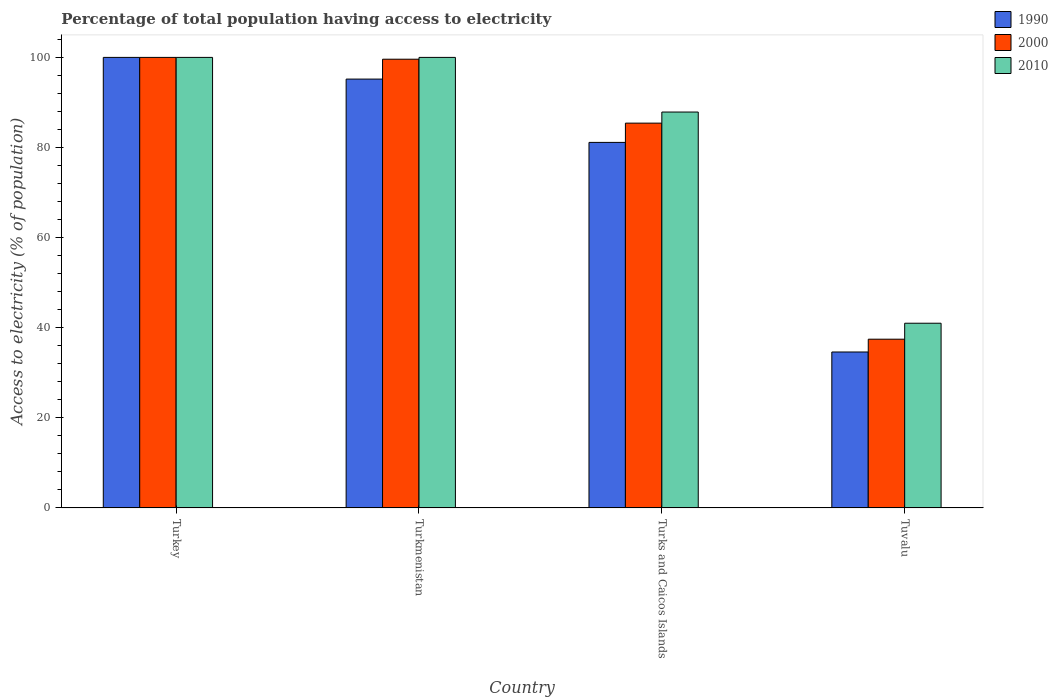Are the number of bars on each tick of the X-axis equal?
Provide a succinct answer. Yes. How many bars are there on the 3rd tick from the right?
Your answer should be compact. 3. What is the label of the 3rd group of bars from the left?
Provide a short and direct response. Turks and Caicos Islands. Across all countries, what is the minimum percentage of population that have access to electricity in 2010?
Provide a succinct answer. 41. In which country was the percentage of population that have access to electricity in 2010 maximum?
Give a very brief answer. Turkey. In which country was the percentage of population that have access to electricity in 2000 minimum?
Keep it short and to the point. Tuvalu. What is the total percentage of population that have access to electricity in 2000 in the graph?
Provide a short and direct response. 322.47. What is the difference between the percentage of population that have access to electricity in 2000 in Turkmenistan and that in Tuvalu?
Give a very brief answer. 62.14. What is the difference between the percentage of population that have access to electricity in 2010 in Tuvalu and the percentage of population that have access to electricity in 2000 in Turks and Caicos Islands?
Your answer should be compact. -44.41. What is the average percentage of population that have access to electricity in 2000 per country?
Offer a terse response. 80.62. What is the difference between the percentage of population that have access to electricity of/in 2000 and percentage of population that have access to electricity of/in 2010 in Turkmenistan?
Offer a terse response. -0.4. What is the ratio of the percentage of population that have access to electricity in 2000 in Turkey to that in Turks and Caicos Islands?
Offer a terse response. 1.17. Is the difference between the percentage of population that have access to electricity in 2000 in Turkmenistan and Turks and Caicos Islands greater than the difference between the percentage of population that have access to electricity in 2010 in Turkmenistan and Turks and Caicos Islands?
Your answer should be compact. Yes. What is the difference between the highest and the second highest percentage of population that have access to electricity in 1990?
Your answer should be compact. -18.86. What is the difference between the highest and the lowest percentage of population that have access to electricity in 2000?
Offer a very short reply. 62.54. In how many countries, is the percentage of population that have access to electricity in 1990 greater than the average percentage of population that have access to electricity in 1990 taken over all countries?
Your response must be concise. 3. Is the sum of the percentage of population that have access to electricity in 2010 in Turkey and Turkmenistan greater than the maximum percentage of population that have access to electricity in 1990 across all countries?
Make the answer very short. Yes. What does the 3rd bar from the left in Turkey represents?
Your answer should be compact. 2010. What does the 1st bar from the right in Tuvalu represents?
Your response must be concise. 2010. Is it the case that in every country, the sum of the percentage of population that have access to electricity in 1990 and percentage of population that have access to electricity in 2010 is greater than the percentage of population that have access to electricity in 2000?
Your response must be concise. Yes. How many bars are there?
Ensure brevity in your answer.  12. Are all the bars in the graph horizontal?
Your answer should be very brief. No. Are the values on the major ticks of Y-axis written in scientific E-notation?
Offer a terse response. No. Does the graph contain any zero values?
Offer a very short reply. No. Does the graph contain grids?
Make the answer very short. No. Where does the legend appear in the graph?
Provide a succinct answer. Top right. How many legend labels are there?
Offer a terse response. 3. What is the title of the graph?
Your answer should be compact. Percentage of total population having access to electricity. Does "2007" appear as one of the legend labels in the graph?
Ensure brevity in your answer.  No. What is the label or title of the Y-axis?
Provide a succinct answer. Access to electricity (% of population). What is the Access to electricity (% of population) in 2000 in Turkey?
Provide a succinct answer. 100. What is the Access to electricity (% of population) in 1990 in Turkmenistan?
Your response must be concise. 95.19. What is the Access to electricity (% of population) in 2000 in Turkmenistan?
Make the answer very short. 99.6. What is the Access to electricity (% of population) in 1990 in Turks and Caicos Islands?
Your answer should be compact. 81.14. What is the Access to electricity (% of population) of 2000 in Turks and Caicos Islands?
Your response must be concise. 85.41. What is the Access to electricity (% of population) in 2010 in Turks and Caicos Islands?
Ensure brevity in your answer.  87.87. What is the Access to electricity (% of population) in 1990 in Tuvalu?
Give a very brief answer. 34.62. What is the Access to electricity (% of population) in 2000 in Tuvalu?
Your answer should be compact. 37.46. What is the Access to electricity (% of population) of 2010 in Tuvalu?
Provide a succinct answer. 41. Across all countries, what is the maximum Access to electricity (% of population) of 1990?
Offer a terse response. 100. Across all countries, what is the maximum Access to electricity (% of population) of 2010?
Ensure brevity in your answer.  100. Across all countries, what is the minimum Access to electricity (% of population) in 1990?
Make the answer very short. 34.62. Across all countries, what is the minimum Access to electricity (% of population) of 2000?
Provide a short and direct response. 37.46. Across all countries, what is the minimum Access to electricity (% of population) in 2010?
Ensure brevity in your answer.  41. What is the total Access to electricity (% of population) in 1990 in the graph?
Your answer should be compact. 310.94. What is the total Access to electricity (% of population) in 2000 in the graph?
Your answer should be compact. 322.47. What is the total Access to electricity (% of population) of 2010 in the graph?
Your answer should be compact. 328.87. What is the difference between the Access to electricity (% of population) in 1990 in Turkey and that in Turkmenistan?
Provide a short and direct response. 4.81. What is the difference between the Access to electricity (% of population) in 2000 in Turkey and that in Turkmenistan?
Your response must be concise. 0.4. What is the difference between the Access to electricity (% of population) in 2010 in Turkey and that in Turkmenistan?
Offer a very short reply. 0. What is the difference between the Access to electricity (% of population) in 1990 in Turkey and that in Turks and Caicos Islands?
Ensure brevity in your answer.  18.86. What is the difference between the Access to electricity (% of population) in 2000 in Turkey and that in Turks and Caicos Islands?
Give a very brief answer. 14.59. What is the difference between the Access to electricity (% of population) of 2010 in Turkey and that in Turks and Caicos Islands?
Give a very brief answer. 12.13. What is the difference between the Access to electricity (% of population) of 1990 in Turkey and that in Tuvalu?
Provide a short and direct response. 65.38. What is the difference between the Access to electricity (% of population) of 2000 in Turkey and that in Tuvalu?
Offer a terse response. 62.54. What is the difference between the Access to electricity (% of population) in 2010 in Turkey and that in Tuvalu?
Your answer should be very brief. 59. What is the difference between the Access to electricity (% of population) of 1990 in Turkmenistan and that in Turks and Caicos Islands?
Ensure brevity in your answer.  14.05. What is the difference between the Access to electricity (% of population) of 2000 in Turkmenistan and that in Turks and Caicos Islands?
Offer a terse response. 14.19. What is the difference between the Access to electricity (% of population) of 2010 in Turkmenistan and that in Turks and Caicos Islands?
Offer a very short reply. 12.13. What is the difference between the Access to electricity (% of population) in 1990 in Turkmenistan and that in Tuvalu?
Ensure brevity in your answer.  60.57. What is the difference between the Access to electricity (% of population) of 2000 in Turkmenistan and that in Tuvalu?
Offer a terse response. 62.14. What is the difference between the Access to electricity (% of population) in 2010 in Turkmenistan and that in Tuvalu?
Provide a short and direct response. 59. What is the difference between the Access to electricity (% of population) of 1990 in Turks and Caicos Islands and that in Tuvalu?
Offer a very short reply. 46.52. What is the difference between the Access to electricity (% of population) of 2000 in Turks and Caicos Islands and that in Tuvalu?
Provide a short and direct response. 47.96. What is the difference between the Access to electricity (% of population) in 2010 in Turks and Caicos Islands and that in Tuvalu?
Provide a short and direct response. 46.87. What is the difference between the Access to electricity (% of population) of 1990 in Turkey and the Access to electricity (% of population) of 2000 in Turkmenistan?
Offer a terse response. 0.4. What is the difference between the Access to electricity (% of population) in 2000 in Turkey and the Access to electricity (% of population) in 2010 in Turkmenistan?
Offer a very short reply. 0. What is the difference between the Access to electricity (% of population) in 1990 in Turkey and the Access to electricity (% of population) in 2000 in Turks and Caicos Islands?
Give a very brief answer. 14.59. What is the difference between the Access to electricity (% of population) of 1990 in Turkey and the Access to electricity (% of population) of 2010 in Turks and Caicos Islands?
Your answer should be compact. 12.13. What is the difference between the Access to electricity (% of population) of 2000 in Turkey and the Access to electricity (% of population) of 2010 in Turks and Caicos Islands?
Your answer should be very brief. 12.13. What is the difference between the Access to electricity (% of population) of 1990 in Turkey and the Access to electricity (% of population) of 2000 in Tuvalu?
Your response must be concise. 62.54. What is the difference between the Access to electricity (% of population) of 1990 in Turkey and the Access to electricity (% of population) of 2010 in Tuvalu?
Your answer should be very brief. 59. What is the difference between the Access to electricity (% of population) of 1990 in Turkmenistan and the Access to electricity (% of population) of 2000 in Turks and Caicos Islands?
Your answer should be very brief. 9.78. What is the difference between the Access to electricity (% of population) of 1990 in Turkmenistan and the Access to electricity (% of population) of 2010 in Turks and Caicos Islands?
Your answer should be very brief. 7.31. What is the difference between the Access to electricity (% of population) of 2000 in Turkmenistan and the Access to electricity (% of population) of 2010 in Turks and Caicos Islands?
Your answer should be very brief. 11.73. What is the difference between the Access to electricity (% of population) of 1990 in Turkmenistan and the Access to electricity (% of population) of 2000 in Tuvalu?
Keep it short and to the point. 57.73. What is the difference between the Access to electricity (% of population) of 1990 in Turkmenistan and the Access to electricity (% of population) of 2010 in Tuvalu?
Give a very brief answer. 54.19. What is the difference between the Access to electricity (% of population) of 2000 in Turkmenistan and the Access to electricity (% of population) of 2010 in Tuvalu?
Give a very brief answer. 58.6. What is the difference between the Access to electricity (% of population) of 1990 in Turks and Caicos Islands and the Access to electricity (% of population) of 2000 in Tuvalu?
Make the answer very short. 43.68. What is the difference between the Access to electricity (% of population) of 1990 in Turks and Caicos Islands and the Access to electricity (% of population) of 2010 in Tuvalu?
Make the answer very short. 40.14. What is the difference between the Access to electricity (% of population) in 2000 in Turks and Caicos Islands and the Access to electricity (% of population) in 2010 in Tuvalu?
Offer a very short reply. 44.41. What is the average Access to electricity (% of population) in 1990 per country?
Offer a terse response. 77.73. What is the average Access to electricity (% of population) in 2000 per country?
Your answer should be compact. 80.62. What is the average Access to electricity (% of population) in 2010 per country?
Your answer should be very brief. 82.22. What is the difference between the Access to electricity (% of population) of 1990 and Access to electricity (% of population) of 2010 in Turkey?
Ensure brevity in your answer.  0. What is the difference between the Access to electricity (% of population) of 1990 and Access to electricity (% of population) of 2000 in Turkmenistan?
Provide a succinct answer. -4.41. What is the difference between the Access to electricity (% of population) of 1990 and Access to electricity (% of population) of 2010 in Turkmenistan?
Give a very brief answer. -4.81. What is the difference between the Access to electricity (% of population) of 2000 and Access to electricity (% of population) of 2010 in Turkmenistan?
Your response must be concise. -0.4. What is the difference between the Access to electricity (% of population) in 1990 and Access to electricity (% of population) in 2000 in Turks and Caicos Islands?
Offer a terse response. -4.28. What is the difference between the Access to electricity (% of population) of 1990 and Access to electricity (% of population) of 2010 in Turks and Caicos Islands?
Your answer should be compact. -6.74. What is the difference between the Access to electricity (% of population) of 2000 and Access to electricity (% of population) of 2010 in Turks and Caicos Islands?
Your response must be concise. -2.46. What is the difference between the Access to electricity (% of population) in 1990 and Access to electricity (% of population) in 2000 in Tuvalu?
Provide a short and direct response. -2.84. What is the difference between the Access to electricity (% of population) of 1990 and Access to electricity (% of population) of 2010 in Tuvalu?
Your answer should be compact. -6.38. What is the difference between the Access to electricity (% of population) of 2000 and Access to electricity (% of population) of 2010 in Tuvalu?
Keep it short and to the point. -3.54. What is the ratio of the Access to electricity (% of population) in 1990 in Turkey to that in Turkmenistan?
Ensure brevity in your answer.  1.05. What is the ratio of the Access to electricity (% of population) of 1990 in Turkey to that in Turks and Caicos Islands?
Make the answer very short. 1.23. What is the ratio of the Access to electricity (% of population) in 2000 in Turkey to that in Turks and Caicos Islands?
Provide a succinct answer. 1.17. What is the ratio of the Access to electricity (% of population) in 2010 in Turkey to that in Turks and Caicos Islands?
Your response must be concise. 1.14. What is the ratio of the Access to electricity (% of population) in 1990 in Turkey to that in Tuvalu?
Your response must be concise. 2.89. What is the ratio of the Access to electricity (% of population) in 2000 in Turkey to that in Tuvalu?
Provide a succinct answer. 2.67. What is the ratio of the Access to electricity (% of population) in 2010 in Turkey to that in Tuvalu?
Ensure brevity in your answer.  2.44. What is the ratio of the Access to electricity (% of population) of 1990 in Turkmenistan to that in Turks and Caicos Islands?
Make the answer very short. 1.17. What is the ratio of the Access to electricity (% of population) in 2000 in Turkmenistan to that in Turks and Caicos Islands?
Give a very brief answer. 1.17. What is the ratio of the Access to electricity (% of population) in 2010 in Turkmenistan to that in Turks and Caicos Islands?
Your response must be concise. 1.14. What is the ratio of the Access to electricity (% of population) of 1990 in Turkmenistan to that in Tuvalu?
Make the answer very short. 2.75. What is the ratio of the Access to electricity (% of population) in 2000 in Turkmenistan to that in Tuvalu?
Keep it short and to the point. 2.66. What is the ratio of the Access to electricity (% of population) of 2010 in Turkmenistan to that in Tuvalu?
Ensure brevity in your answer.  2.44. What is the ratio of the Access to electricity (% of population) of 1990 in Turks and Caicos Islands to that in Tuvalu?
Give a very brief answer. 2.34. What is the ratio of the Access to electricity (% of population) in 2000 in Turks and Caicos Islands to that in Tuvalu?
Your answer should be compact. 2.28. What is the ratio of the Access to electricity (% of population) of 2010 in Turks and Caicos Islands to that in Tuvalu?
Your answer should be compact. 2.14. What is the difference between the highest and the second highest Access to electricity (% of population) in 1990?
Your response must be concise. 4.81. What is the difference between the highest and the second highest Access to electricity (% of population) of 2000?
Provide a succinct answer. 0.4. What is the difference between the highest and the lowest Access to electricity (% of population) in 1990?
Provide a succinct answer. 65.38. What is the difference between the highest and the lowest Access to electricity (% of population) in 2000?
Give a very brief answer. 62.54. 